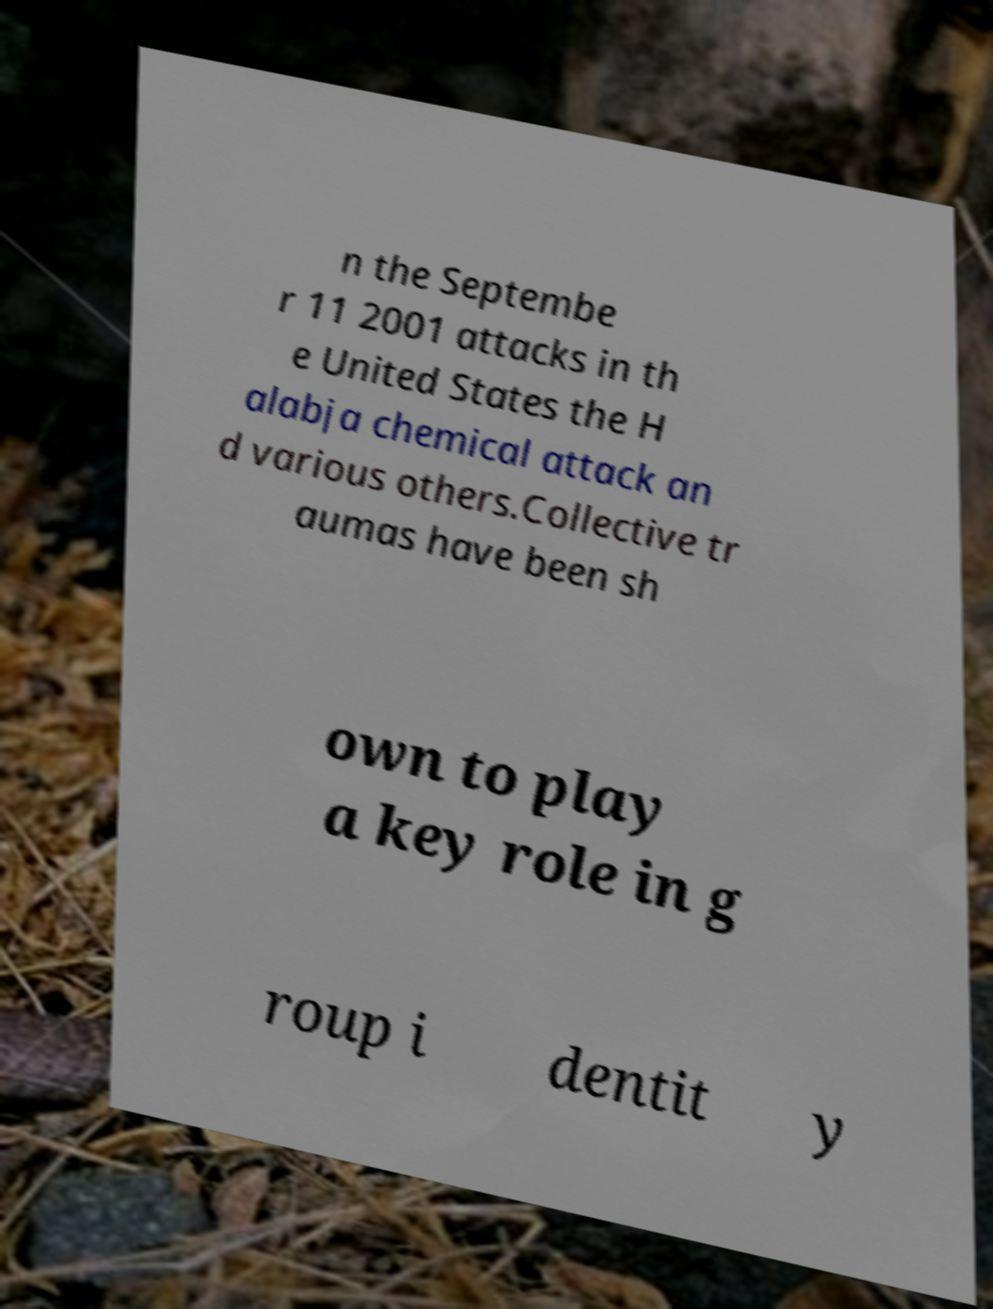Could you assist in decoding the text presented in this image and type it out clearly? n the Septembe r 11 2001 attacks in th e United States the H alabja chemical attack an d various others.Collective tr aumas have been sh own to play a key role in g roup i dentit y 